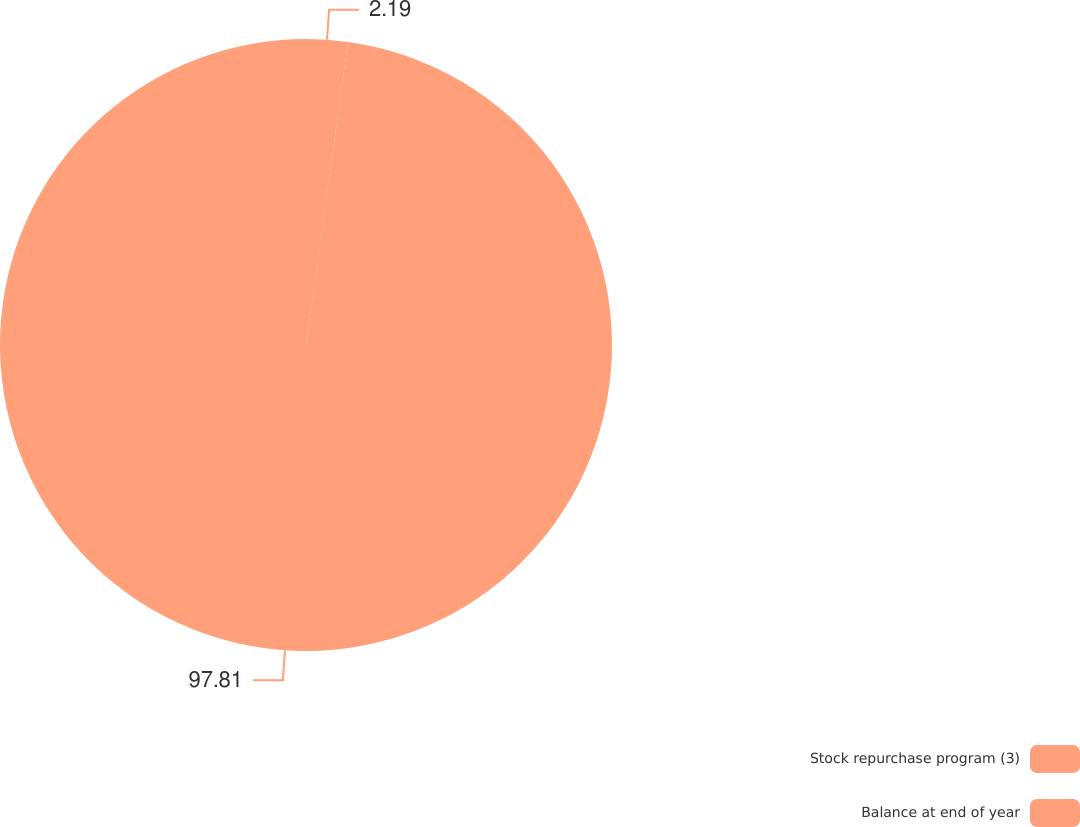<chart> <loc_0><loc_0><loc_500><loc_500><pie_chart><fcel>Stock repurchase program (3)<fcel>Balance at end of year<nl><fcel>2.19%<fcel>97.81%<nl></chart> 